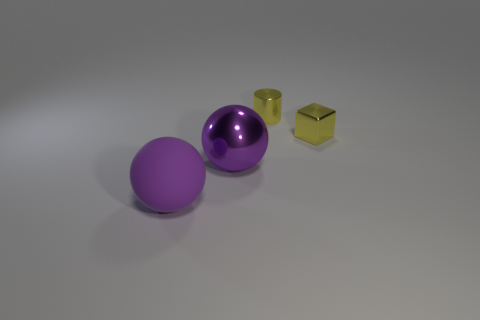Add 2 shiny cubes. How many objects exist? 6 Subtract all cylinders. How many objects are left? 3 Add 4 big metal things. How many big metal things are left? 5 Add 3 large purple balls. How many large purple balls exist? 5 Subtract 1 yellow cylinders. How many objects are left? 3 Subtract all small green rubber balls. Subtract all blocks. How many objects are left? 3 